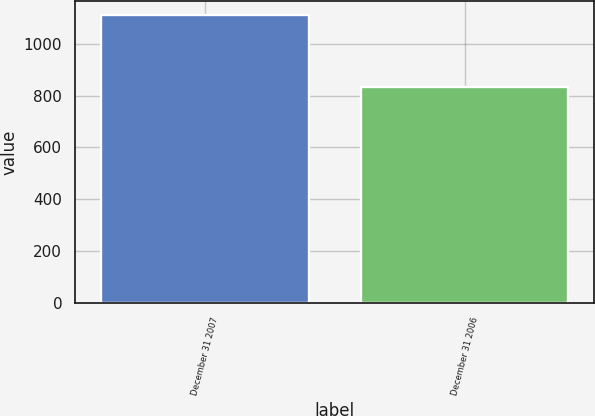<chart> <loc_0><loc_0><loc_500><loc_500><bar_chart><fcel>December 31 2007<fcel>December 31 2006<nl><fcel>1110<fcel>834<nl></chart> 